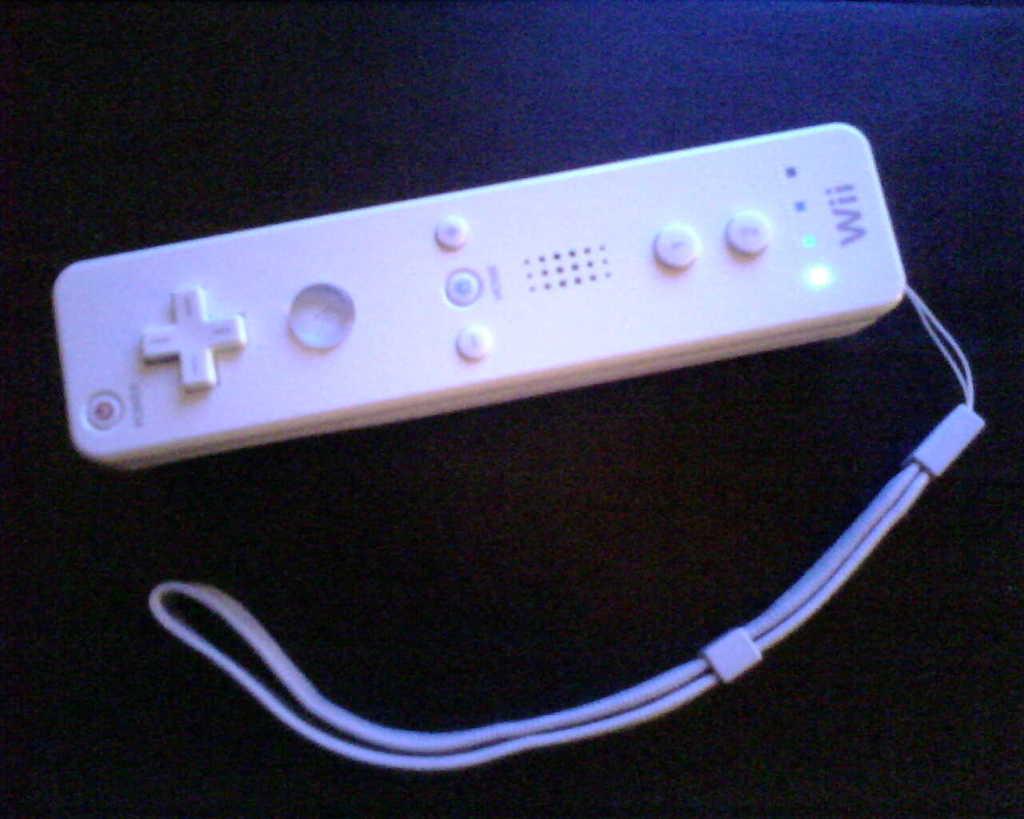This is a remote to what video game system?
Your answer should be very brief. Wii. 